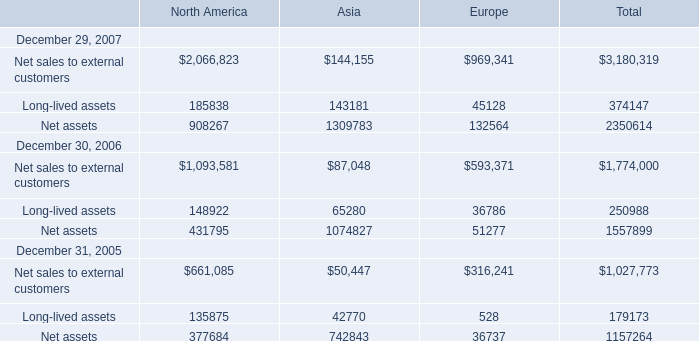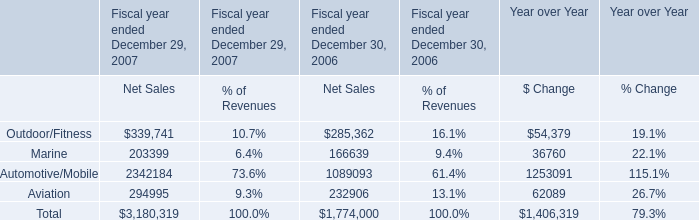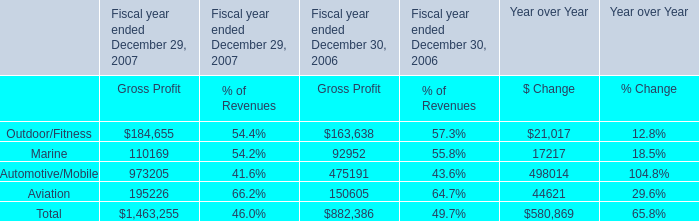What's the sum of Net sales to external customers of Asia, and Aviation of Fiscal year ended December 29, 2007 Gross Profit ? 
Computations: (144155.0 + 195226.0)
Answer: 339381.0. 